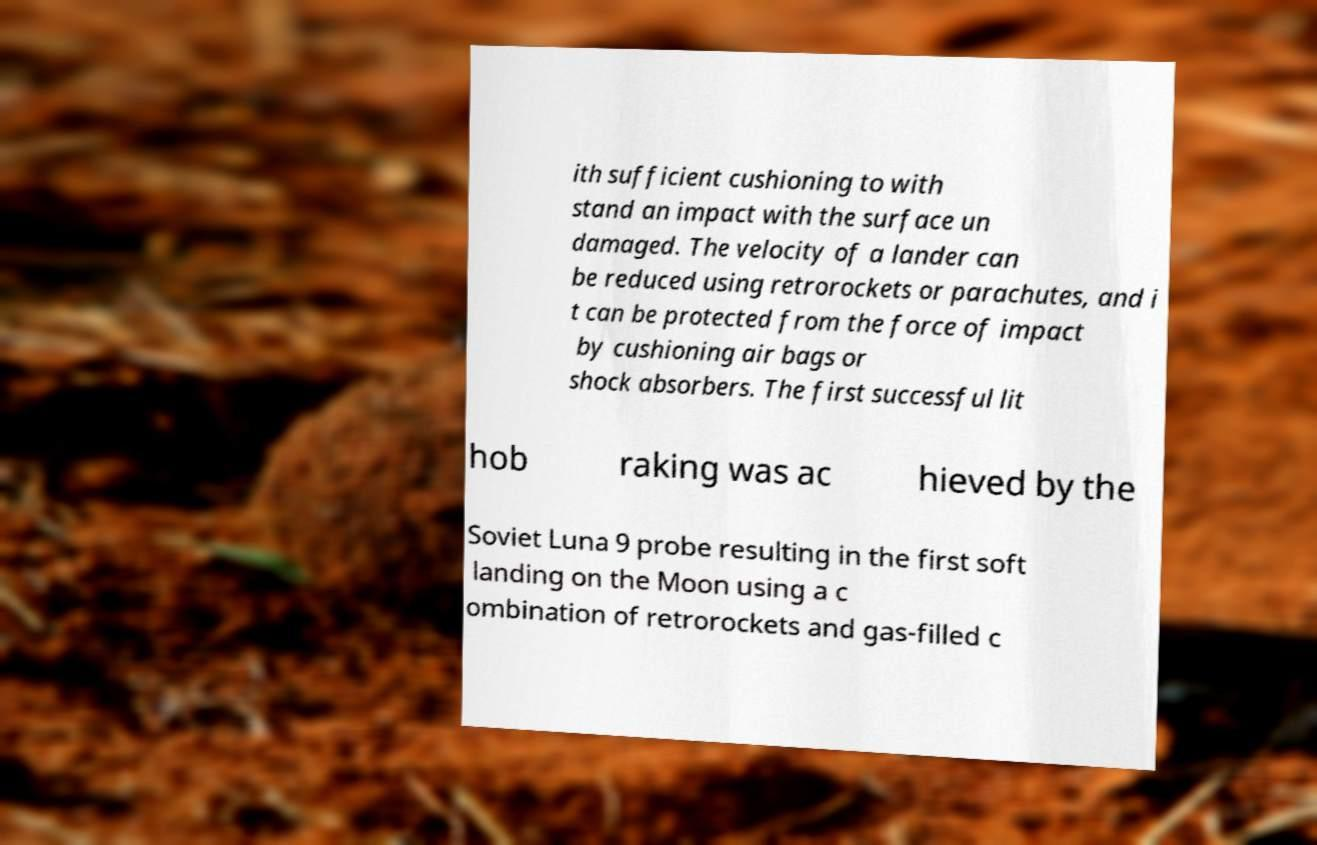Please read and relay the text visible in this image. What does it say? ith sufficient cushioning to with stand an impact with the surface un damaged. The velocity of a lander can be reduced using retrorockets or parachutes, and i t can be protected from the force of impact by cushioning air bags or shock absorbers. The first successful lit hob raking was ac hieved by the Soviet Luna 9 probe resulting in the first soft landing on the Moon using a c ombination of retrorockets and gas-filled c 